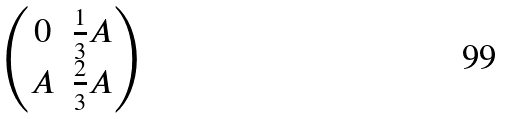Convert formula to latex. <formula><loc_0><loc_0><loc_500><loc_500>\begin{pmatrix} 0 & \frac { 1 } { 3 } A \\ A & \frac { 2 } { 3 } A \end{pmatrix}</formula> 